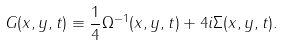<formula> <loc_0><loc_0><loc_500><loc_500>G ( x , y , t ) \equiv \frac { 1 } { 4 } \Omega ^ { - 1 } ( x , y , t ) + 4 i \Sigma ( x , y , t ) .</formula> 